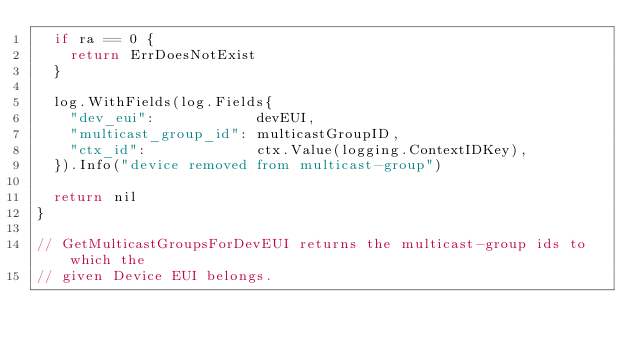<code> <loc_0><loc_0><loc_500><loc_500><_Go_>	if ra == 0 {
		return ErrDoesNotExist
	}

	log.WithFields(log.Fields{
		"dev_eui":            devEUI,
		"multicast_group_id": multicastGroupID,
		"ctx_id":             ctx.Value(logging.ContextIDKey),
	}).Info("device removed from multicast-group")

	return nil
}

// GetMulticastGroupsForDevEUI returns the multicast-group ids to which the
// given Device EUI belongs.</code> 